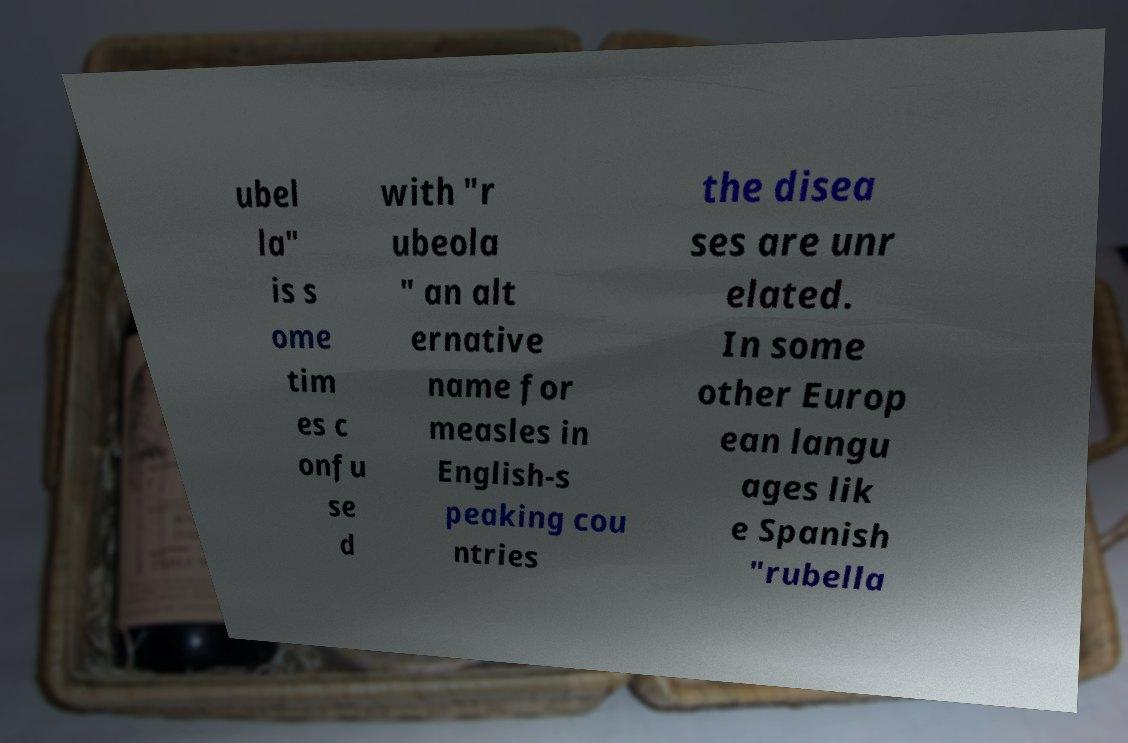For documentation purposes, I need the text within this image transcribed. Could you provide that? ubel la" is s ome tim es c onfu se d with "r ubeola " an alt ernative name for measles in English-s peaking cou ntries the disea ses are unr elated. In some other Europ ean langu ages lik e Spanish "rubella 